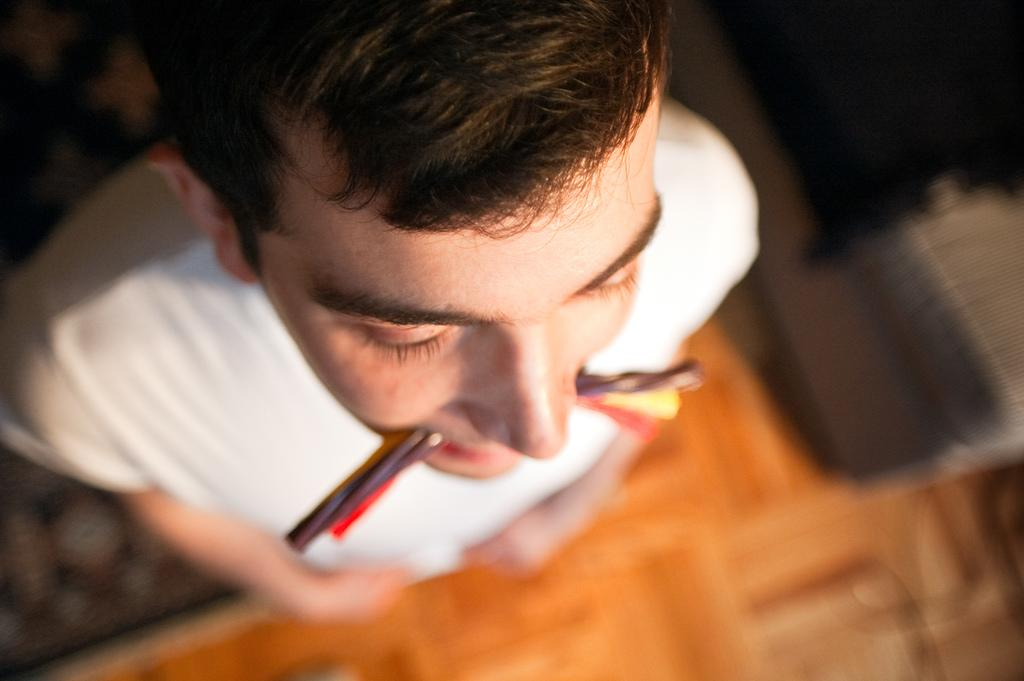What is the man in the image doing? The man is standing in the image. What is the man wearing? The man is wearing a white t-shirt. What is the man holding in his mouth? The man is holding a colorful object in his mouth. What can be seen in the rest of the image? The remaining portion of the image is blurred. What type of goldfish can be seen swimming in the calendar in the image? There is no goldfish or calendar present in the image. 